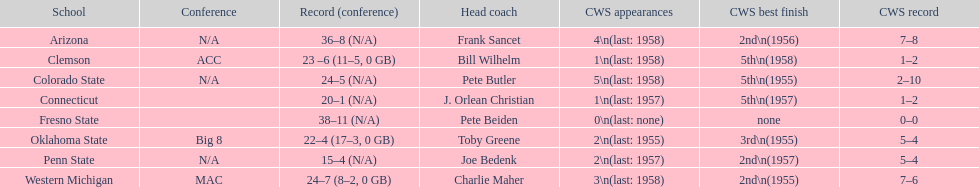Which school has no cws appearances? Fresno State. 